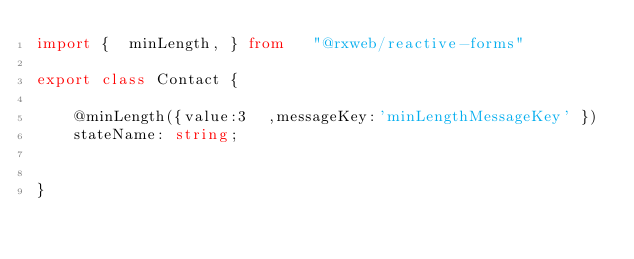<code> <loc_0><loc_0><loc_500><loc_500><_TypeScript_>import {  minLength, } from   "@rxweb/reactive-forms"   

export class Contact {

	@minLength({value:3  ,messageKey:'minLengthMessageKey' }) 
	stateName: string;
	
	
}
</code> 